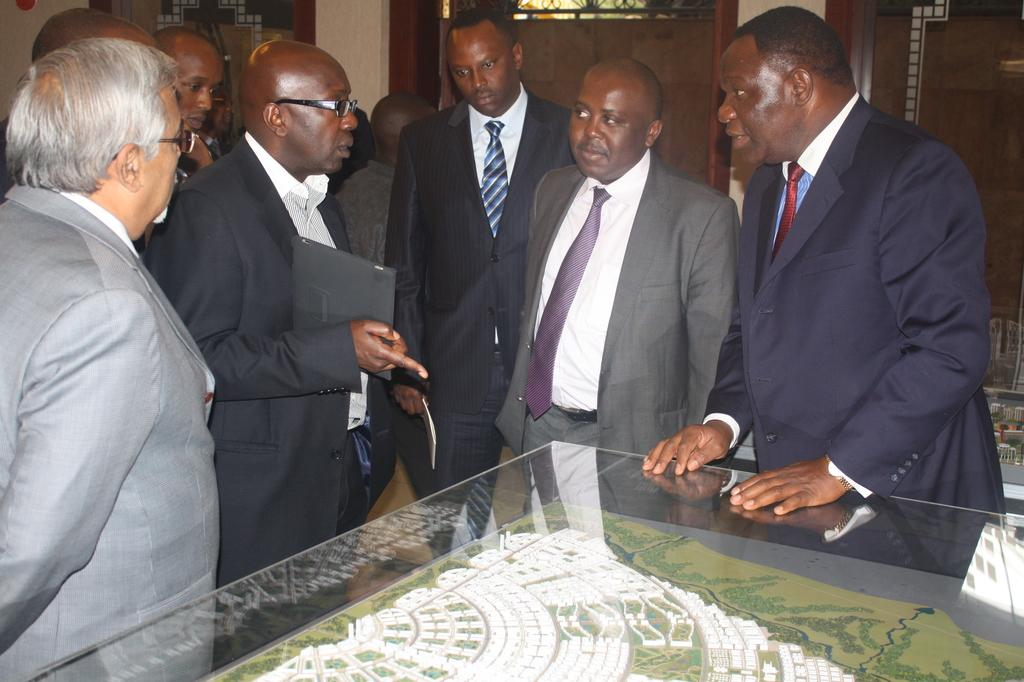What is happening in the image? There are people standing around a table in the image. Can you describe the setting of the image? There are doors in the middle of a wall in the background of the image. Is there a basketball game happening in the image? No, there is no basketball game present in the image. What type of machine can be seen in the image? There is no machine visible in the image. 